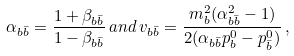Convert formula to latex. <formula><loc_0><loc_0><loc_500><loc_500>\alpha _ { b \bar { b } } = \frac { 1 + \beta _ { b \bar { b } } } { 1 - \beta _ { b \bar { b } } } \, a n d \, v _ { b \bar { b } } = \frac { m _ { b } ^ { 2 } ( \alpha _ { b \bar { b } } ^ { 2 } - 1 ) } { 2 ( \alpha _ { b \bar { b } } p _ { b } ^ { 0 } - p _ { \bar { b } } ^ { 0 } ) } \, ,</formula> 